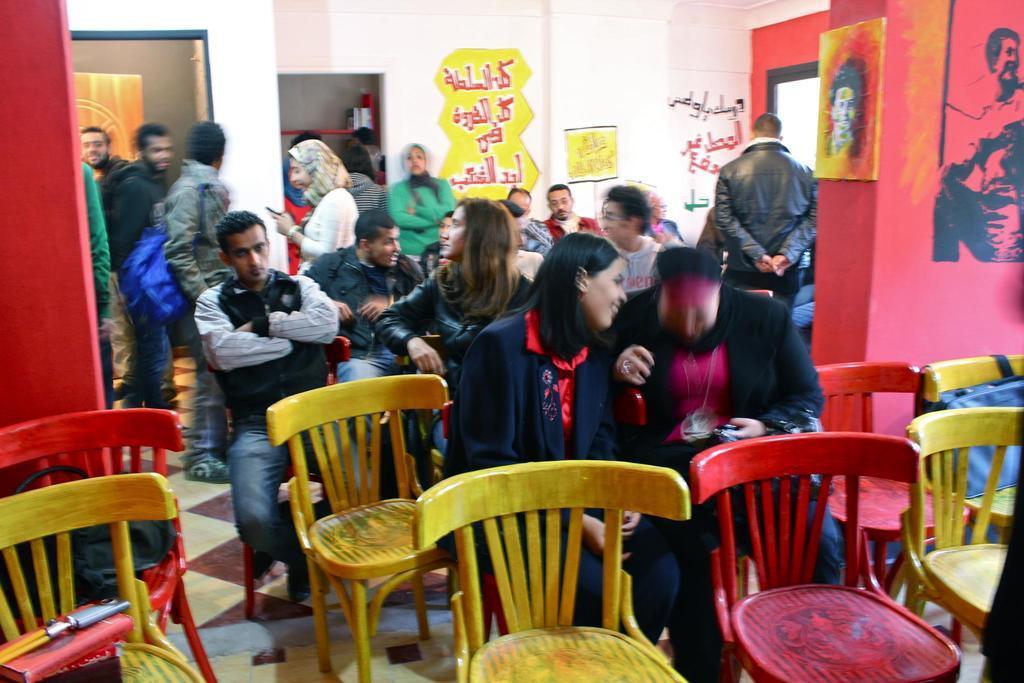How would you summarize this image in a sentence or two? In this picture we can see some persons are sitting on the chairs. This is floor and there is a wall. On the wall there is a frame. Even we can see some persons are standing on the floor. 